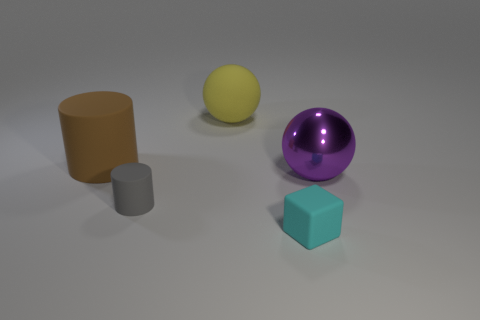Can you describe the shapes and colors of the objects in the image? Certainly! There are four objects: a tall brown cylinder, a small gray cylinder, a yellow sphere, and a purple sphere with a reflective surface. In the corner is a small cube with a teal-like color. What can you tell me about the lighting in the scene? The lighting seems diffused, creating soft shadows directly beneath the objects. There is no strong directional light, which indicates that either there is a wide light source above or multiple sources contributing to the even lighting. 